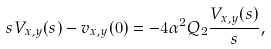Convert formula to latex. <formula><loc_0><loc_0><loc_500><loc_500>s V _ { x , y } ( s ) - v _ { x , y } ( 0 ) = - 4 \alpha ^ { 2 } Q _ { 2 } \frac { V _ { x , y } ( s ) } { s } ,</formula> 